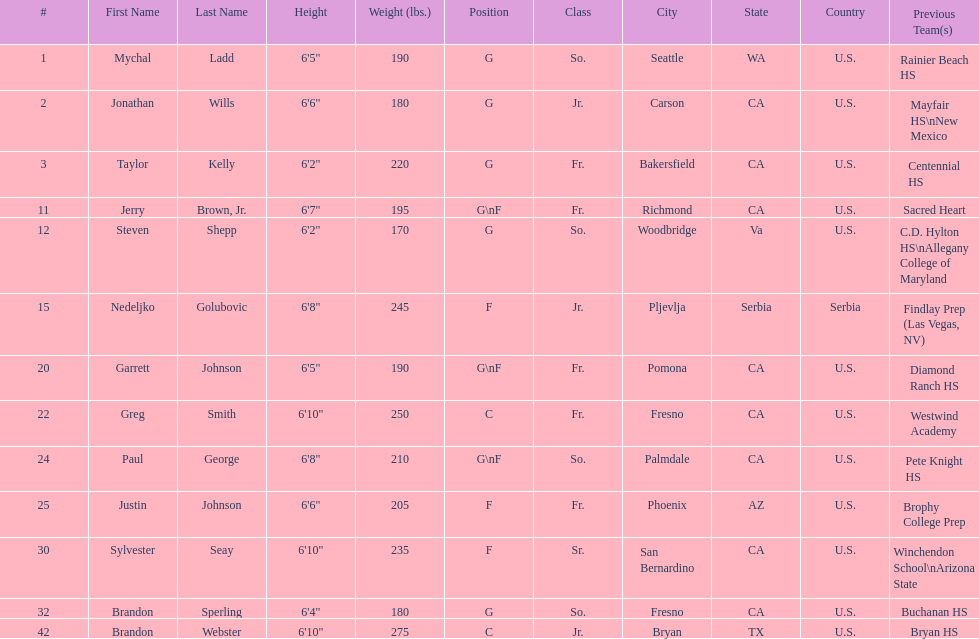How many players hometowns are outside of california? 5. 